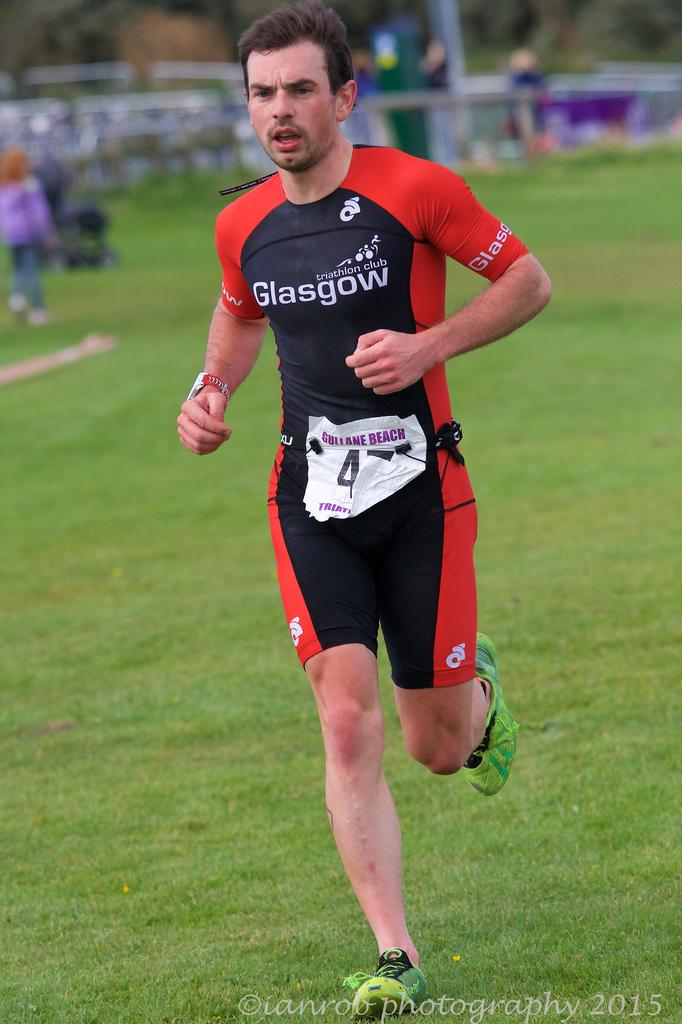What is the person in the image doing? The person is running on the ground. What type of vegetation can be seen in the image? There are trees in the image. What is the surface that the person is running on? There is grass on the ground. Are there any other people visible in the image? Yes, there are children at the back side of the person running. What objects can be seen on the surface? There are objects on the surface, but their specific nature is not mentioned in the facts. What type of legs does the person running have in the image? The facts provided do not mention the person's legs or any specific details about them. What is the person offering to the children in the image? There is no indication in the image that the person is offering anything to the children. 